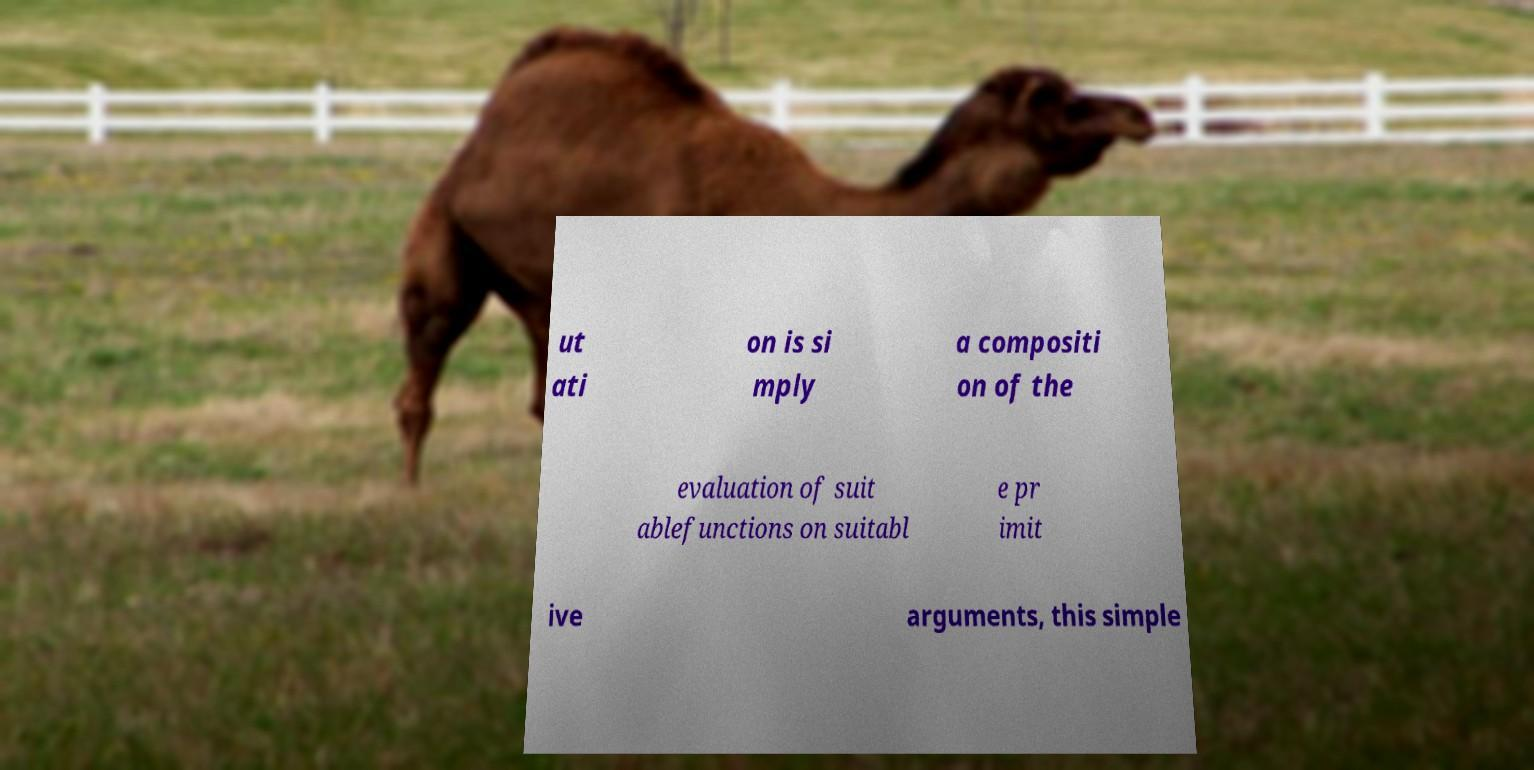Please read and relay the text visible in this image. What does it say? ut ati on is si mply a compositi on of the evaluation of suit ablefunctions on suitabl e pr imit ive arguments, this simple 